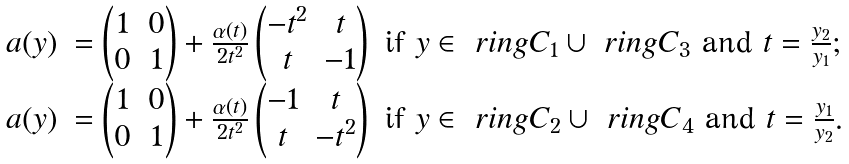<formula> <loc_0><loc_0><loc_500><loc_500>\begin{array} { l l } a ( y ) & = \begin{pmatrix} 1 & 0 \\ 0 & 1 \end{pmatrix} + \frac { \alpha ( t ) } { 2 t ^ { 2 } } \begin{pmatrix} - t ^ { 2 } & t \\ t & - 1 \end{pmatrix} \text { if } y \in \ r i n g { C } _ { 1 } \cup \ r i n g { C } _ { 3 } \text { and } t = \frac { y _ { 2 } } { y _ { 1 } } ; \\ a ( y ) & = \begin{pmatrix} 1 & 0 \\ 0 & 1 \end{pmatrix} + \frac { \alpha ( t ) } { 2 t ^ { 2 } } \begin{pmatrix} - 1 & t \\ t & - t ^ { 2 } \end{pmatrix} \text { if } y \in \ r i n g { C } _ { 2 } \cup \ r i n g { C } _ { 4 } \text { and } t = \frac { y _ { 1 } } { y _ { 2 } } . \end{array}</formula> 